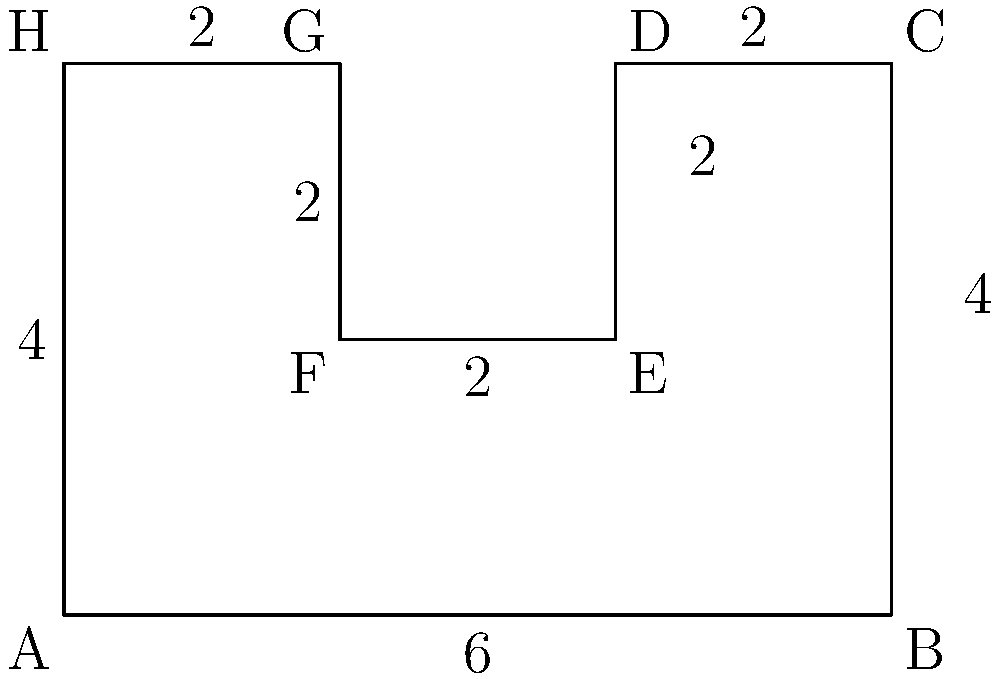In your e-book layout design, you've created an irregular polygon representing the shape of a page spread. The dimensions are given in the diagram (in units of centimeters). Calculate the total area of this irregular polygon. To calculate the area of this irregular polygon, we can break it down into simpler shapes:

1. First, let's divide the shape into a large rectangle and two smaller rectangles.

2. The large rectangle:
   Width = 6 cm
   Height = 4 cm
   Area of large rectangle = $6 \times 4 = 24$ cm²

3. The two smaller rectangles on the left and right:
   Width = 2 cm
   Height = 2 cm
   Area of each small rectangle = $2 \times 2 = 4$ cm²
   Total area of both small rectangles = $4 \times 2 = 8$ cm²

4. Now, we need to subtract the area of the small rectangles from the large rectangle:
   Total area = Area of large rectangle - Area of small rectangles
               = $24 - 8 = 16$ cm²

Therefore, the total area of the irregular polygon is 16 cm².
Answer: 16 cm² 